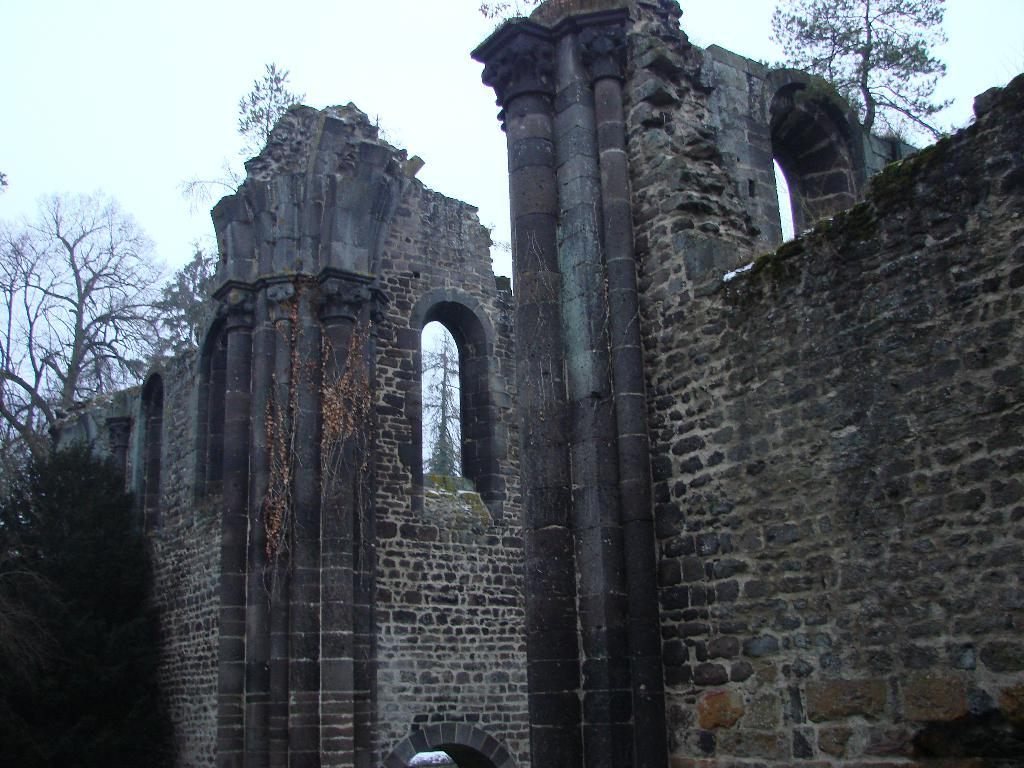What type of structures can be seen in the image? There are walls in the image. What openings are present in the walls? There are windows in the image. What type of vegetation is visible in the image? There are trees in the image. What can be seen in the distance in the image? The sky is visible in the background of the image. How many snakes can be seen slithering on the walls in the image? There are no snakes present in the image; the walls are clear of any such creatures. 